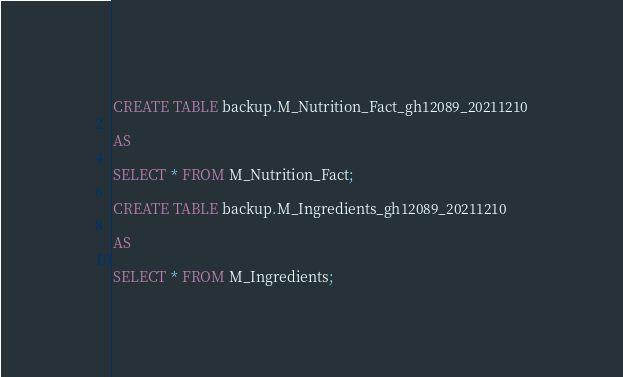<code> <loc_0><loc_0><loc_500><loc_500><_SQL_>CREATE TABLE backup.M_Nutrition_Fact_gh12089_20211210

AS

SELECT * FROM M_Nutrition_Fact;

CREATE TABLE backup.M_Ingredients_gh12089_20211210

AS

SELECT * FROM M_Ingredients;</code> 